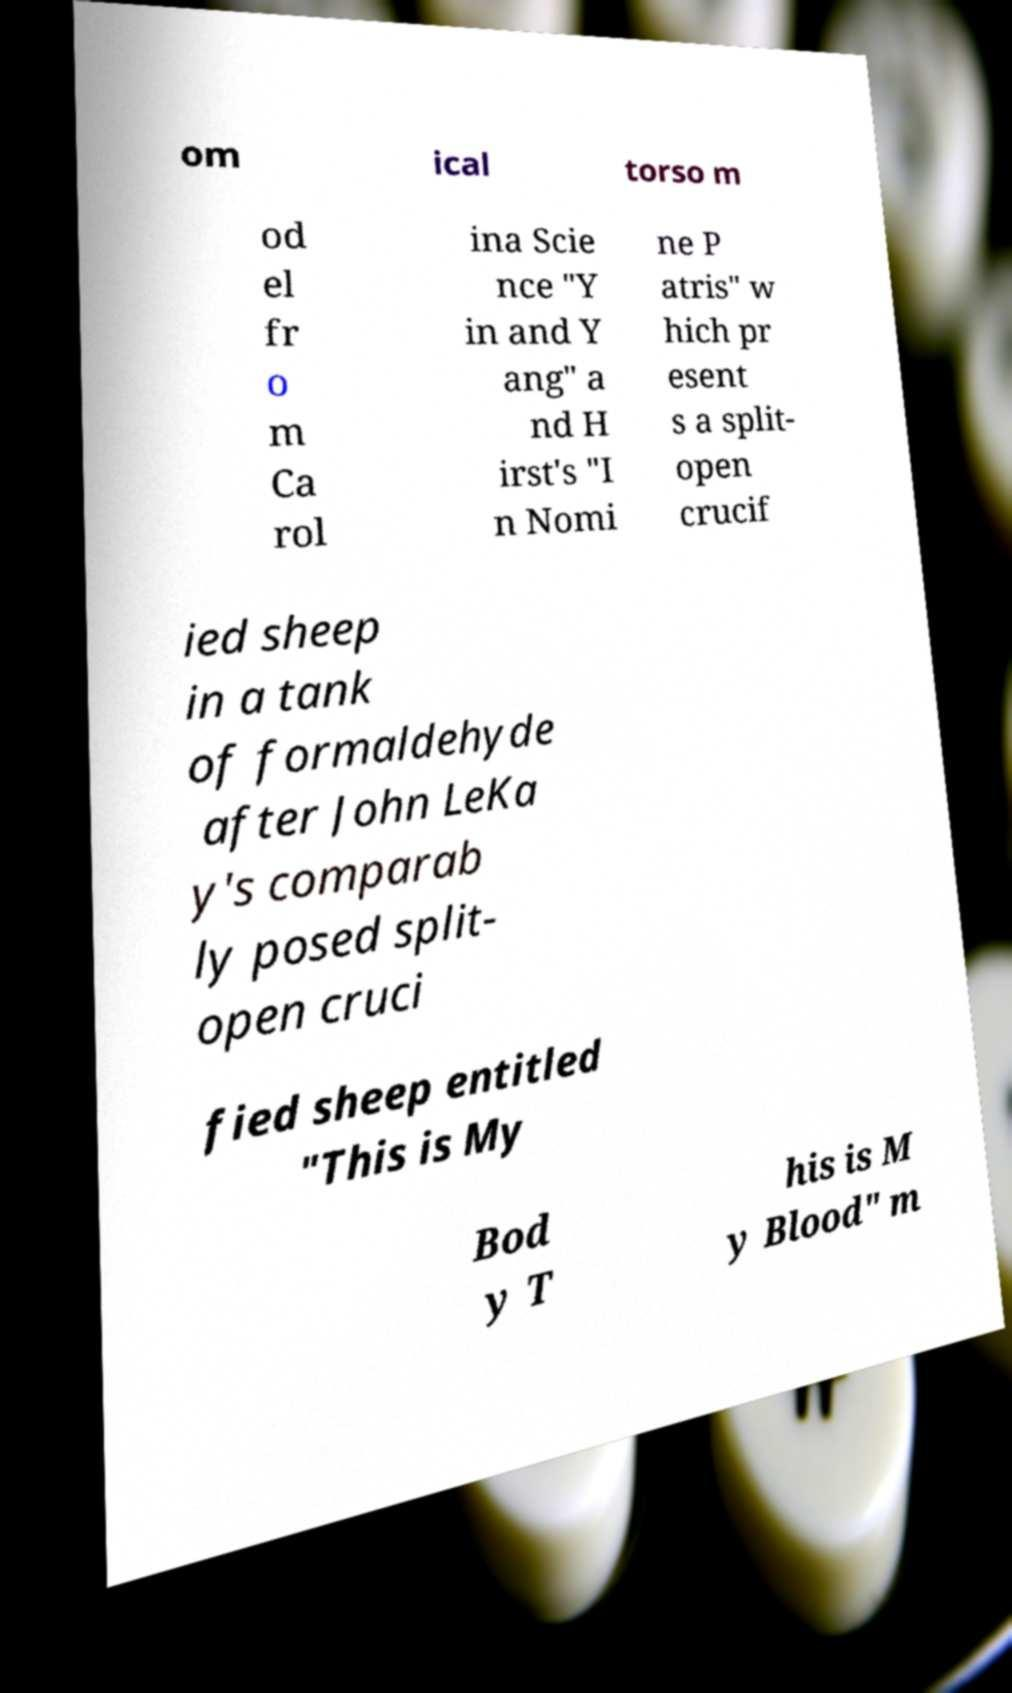Can you accurately transcribe the text from the provided image for me? om ical torso m od el fr o m Ca rol ina Scie nce "Y in and Y ang" a nd H irst's "I n Nomi ne P atris" w hich pr esent s a split- open crucif ied sheep in a tank of formaldehyde after John LeKa y's comparab ly posed split- open cruci fied sheep entitled "This is My Bod y T his is M y Blood" m 